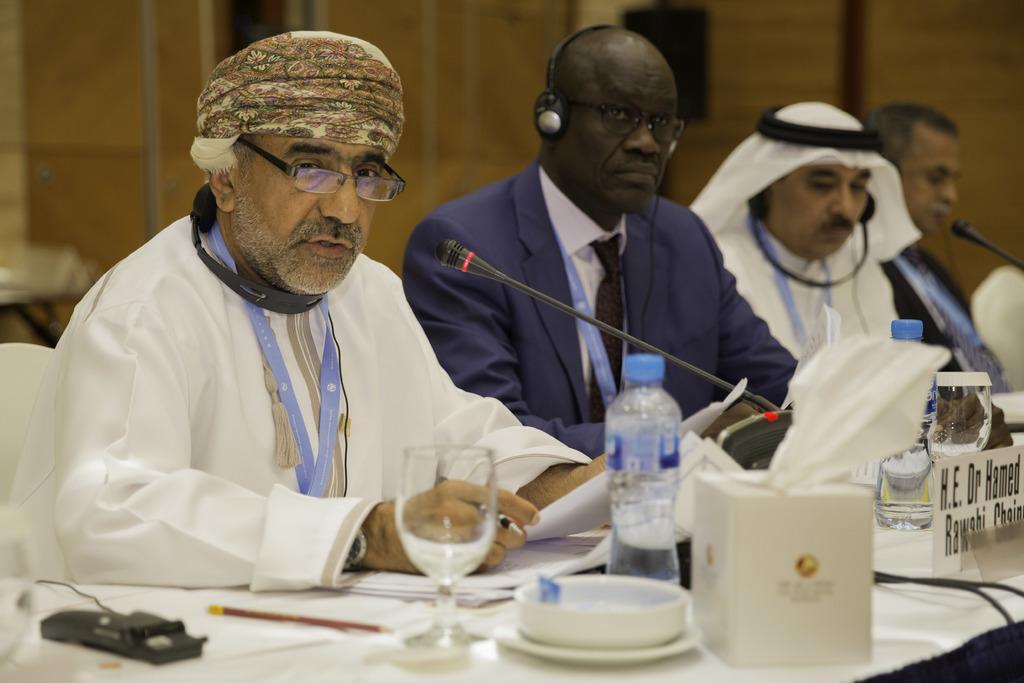How would you summarize this image in a sentence or two? In this picture there is a man who is wearing cap, spectacle, headphone and white dress. He is holding a paper and sitting on the chair near to the table. On the table I can see the water glass, water bottle, tissue paper box, cup, saucer, nameplate, papers and other objects. Beside him there is a black man who is wearing suit. Beside him I can see two persons who are sitting in front of the mic. In the back I can see the blur image. 